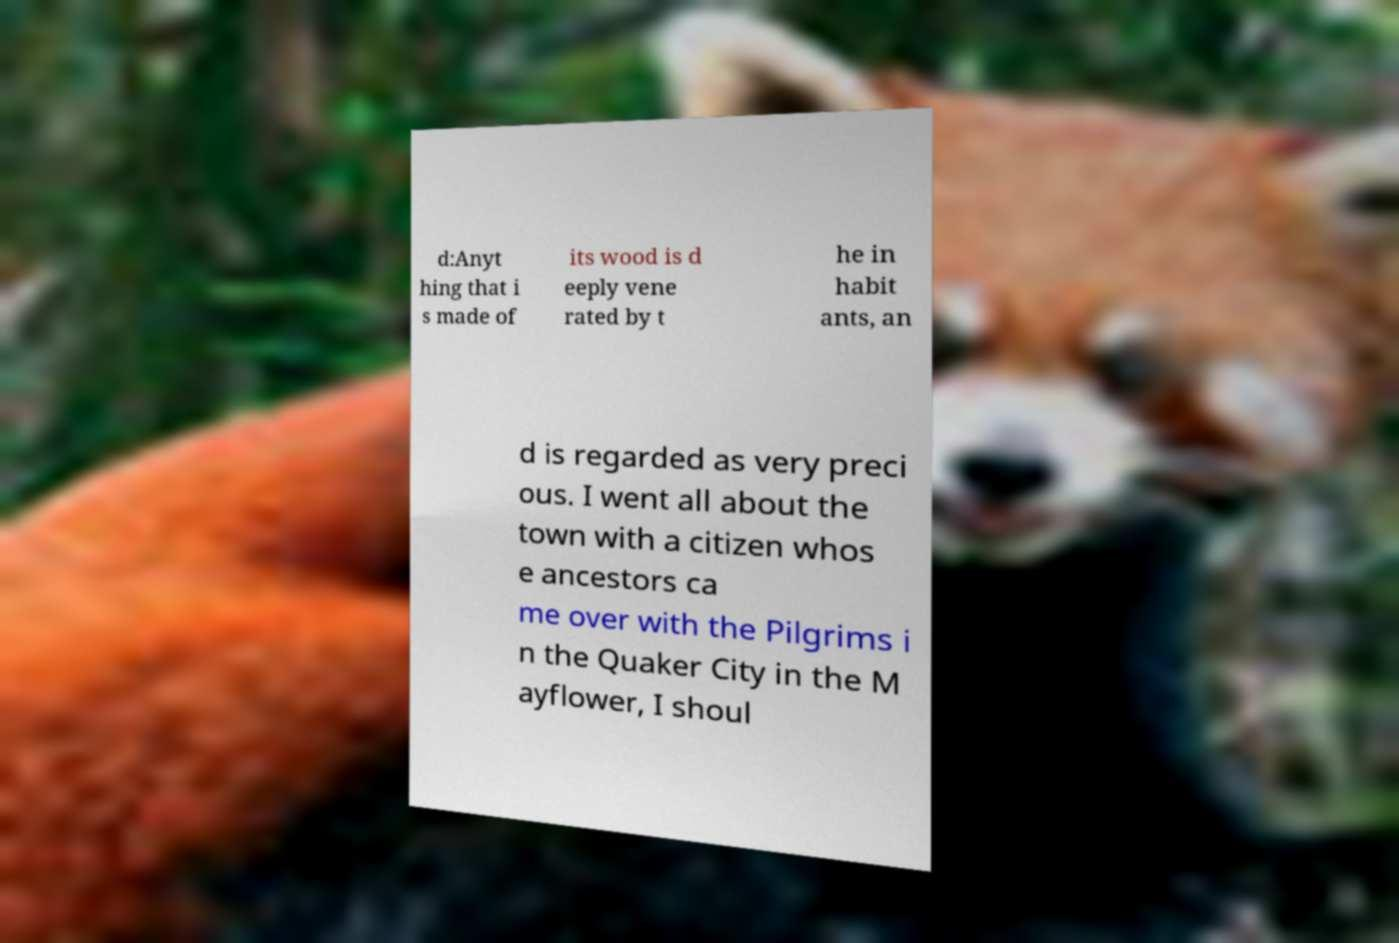Please read and relay the text visible in this image. What does it say? d:Anyt hing that i s made of its wood is d eeply vene rated by t he in habit ants, an d is regarded as very preci ous. I went all about the town with a citizen whos e ancestors ca me over with the Pilgrims i n the Quaker City in the M ayflower, I shoul 